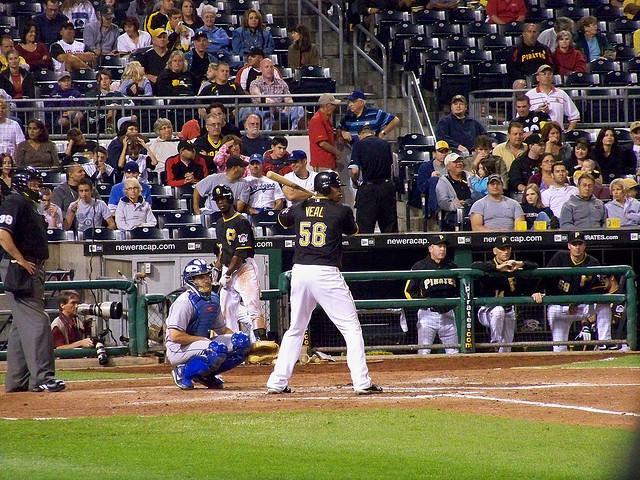What is the number of the batter?
Write a very short answer. 58. What color is the player's uniform?
Give a very brief answer. Black. What is the number on the batter's shirt?
Concise answer only. 58. What color is the batter's uniform?
Quick response, please. Black and white. What is the batter last name?
Be succinct. Neal. Is the batter right-handed?
Concise answer only. No. Is there an umpire?
Be succinct. Yes. Is the catcher squatting because he is tired?
Quick response, please. No. 